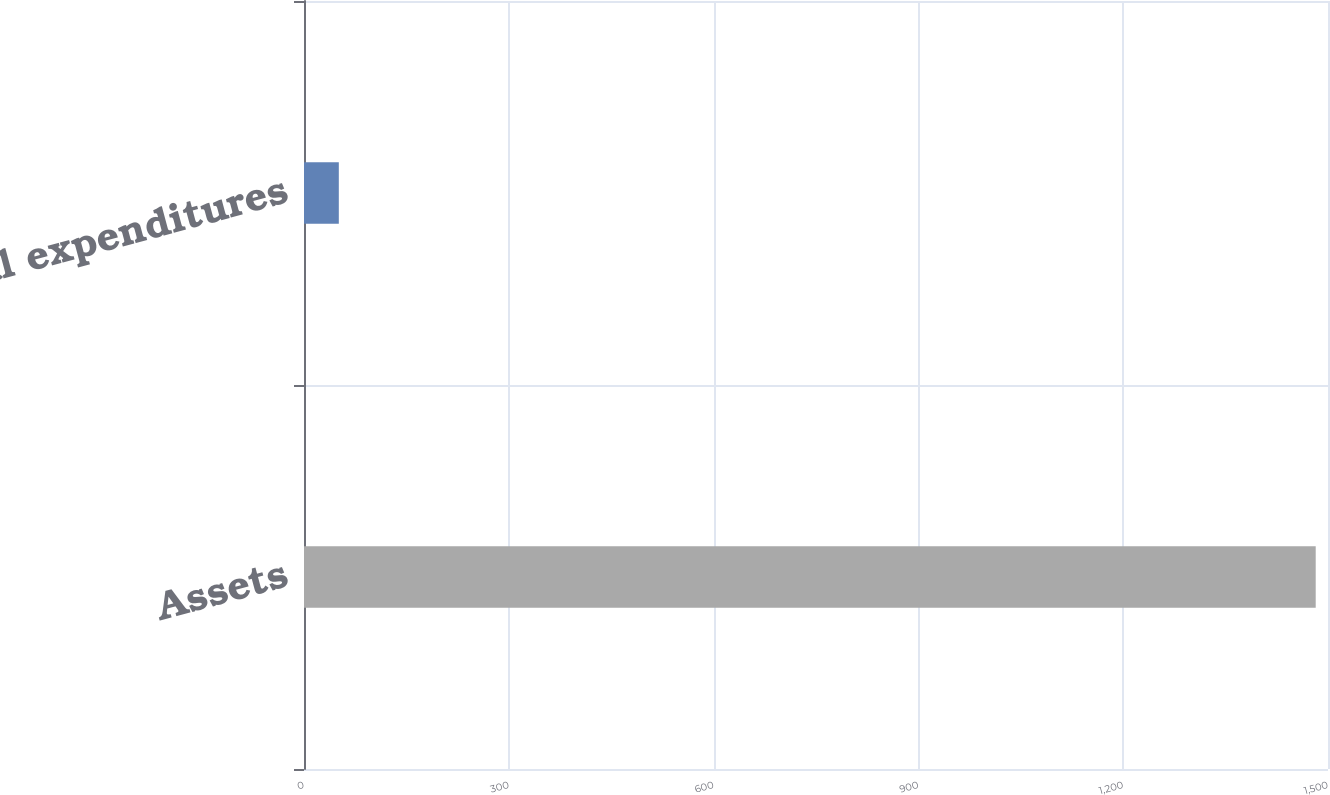Convert chart to OTSL. <chart><loc_0><loc_0><loc_500><loc_500><bar_chart><fcel>Assets<fcel>Capital expenditures<nl><fcel>1482<fcel>51<nl></chart> 